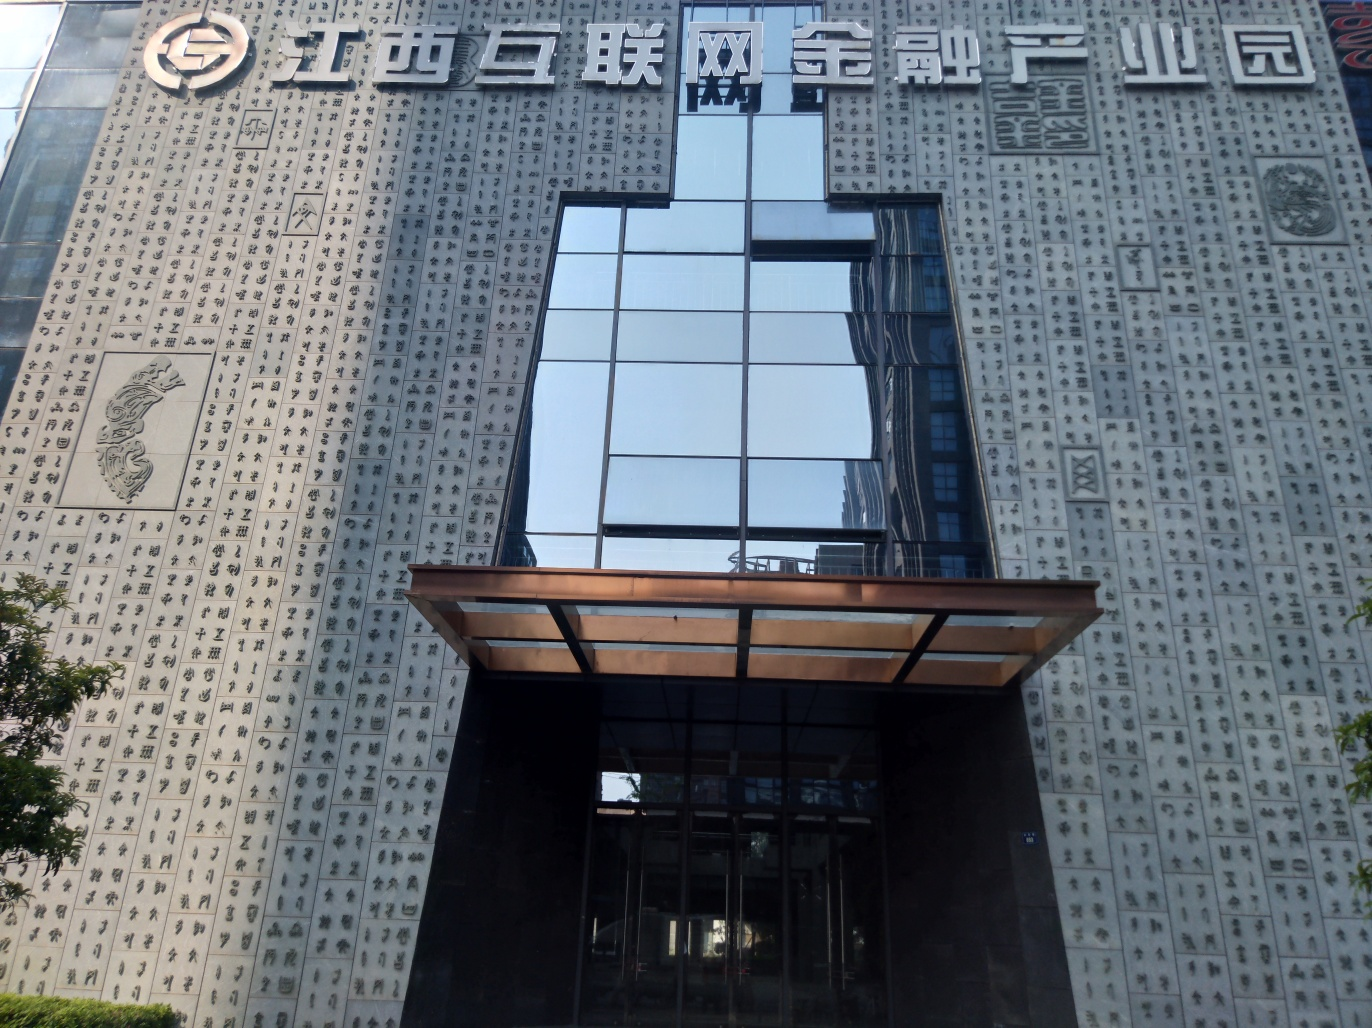Can the details on the walls be distinguished?
A. Yes
B. No
C. Pixelated
D. Blurry
Answer with the option's letter from the given choices directly.
 A. 